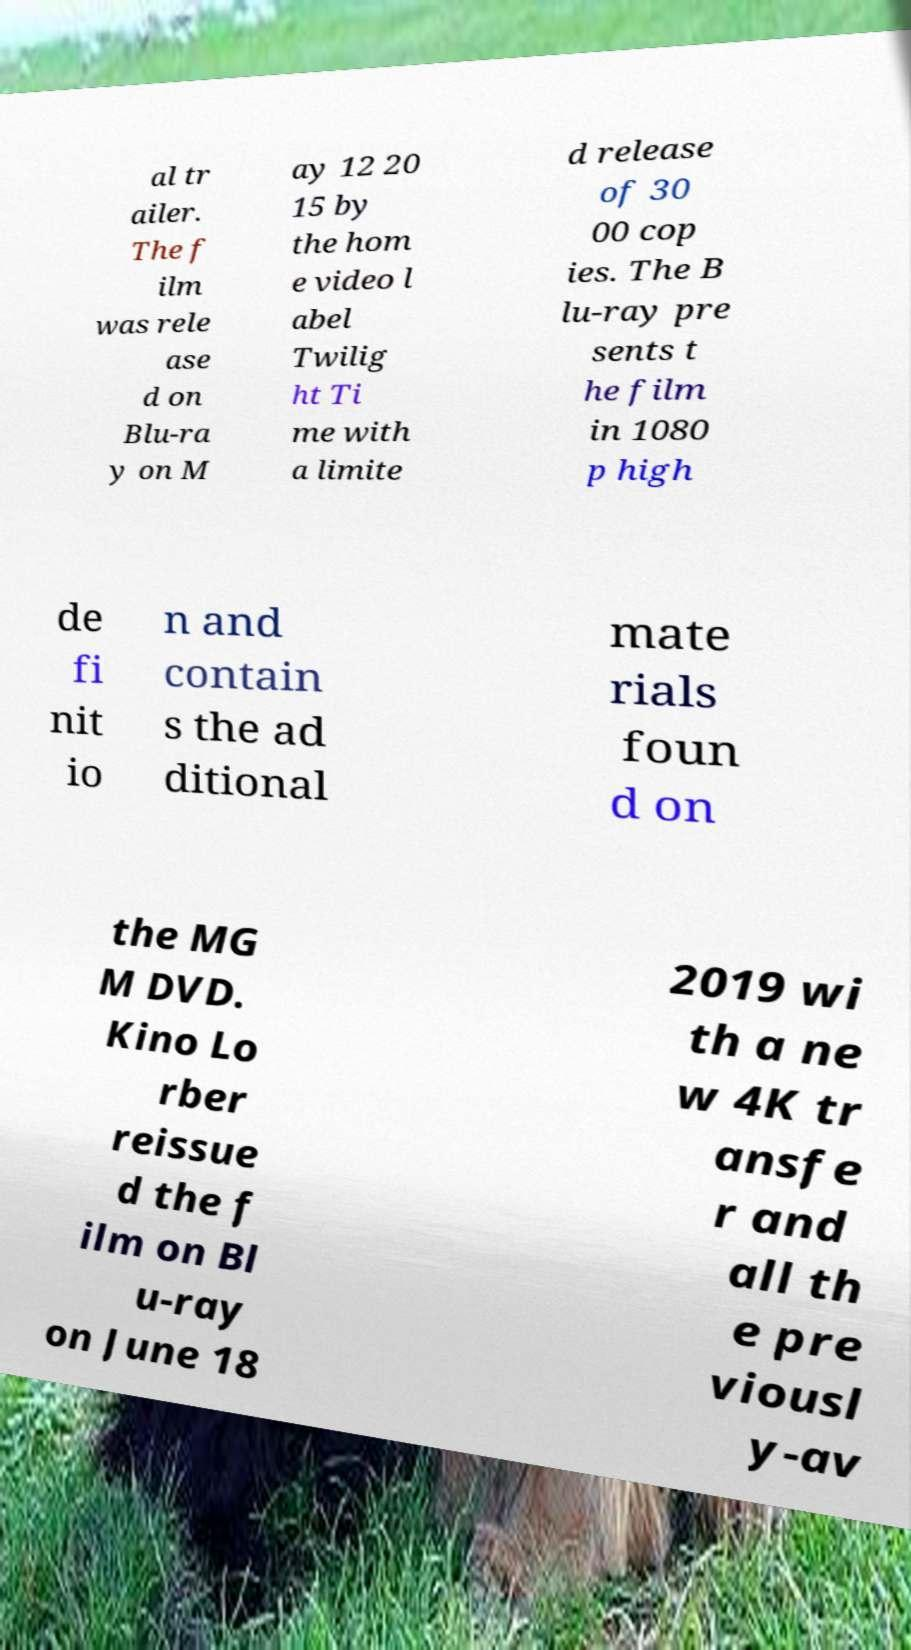What messages or text are displayed in this image? I need them in a readable, typed format. al tr ailer. The f ilm was rele ase d on Blu-ra y on M ay 12 20 15 by the hom e video l abel Twilig ht Ti me with a limite d release of 30 00 cop ies. The B lu-ray pre sents t he film in 1080 p high de fi nit io n and contain s the ad ditional mate rials foun d on the MG M DVD. Kino Lo rber reissue d the f ilm on Bl u-ray on June 18 2019 wi th a ne w 4K tr ansfe r and all th e pre viousl y-av 